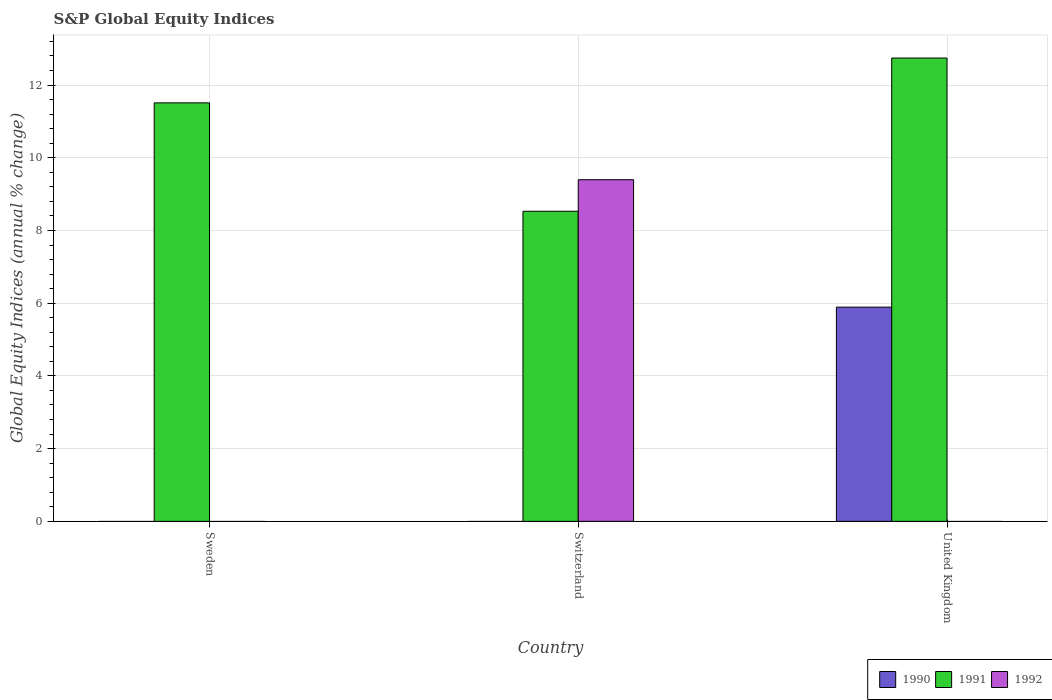Are the number of bars per tick equal to the number of legend labels?
Give a very brief answer. No. How many bars are there on the 3rd tick from the right?
Ensure brevity in your answer.  1. What is the global equity indices in 1990 in Sweden?
Make the answer very short. 0. Across all countries, what is the maximum global equity indices in 1992?
Your answer should be very brief. 9.4. In which country was the global equity indices in 1992 maximum?
Offer a terse response. Switzerland. What is the total global equity indices in 1992 in the graph?
Ensure brevity in your answer.  9.4. What is the difference between the global equity indices in 1991 in Switzerland and that in United Kingdom?
Make the answer very short. -4.21. What is the difference between the global equity indices in 1991 in Sweden and the global equity indices in 1992 in United Kingdom?
Provide a short and direct response. 11.51. What is the average global equity indices in 1991 per country?
Your answer should be compact. 10.93. What is the ratio of the global equity indices in 1991 in Switzerland to that in United Kingdom?
Keep it short and to the point. 0.67. What is the difference between the highest and the second highest global equity indices in 1991?
Ensure brevity in your answer.  -2.98. What is the difference between the highest and the lowest global equity indices in 1991?
Ensure brevity in your answer.  4.21. In how many countries, is the global equity indices in 1991 greater than the average global equity indices in 1991 taken over all countries?
Offer a very short reply. 2. Is the sum of the global equity indices in 1991 in Switzerland and United Kingdom greater than the maximum global equity indices in 1992 across all countries?
Keep it short and to the point. Yes. Is it the case that in every country, the sum of the global equity indices in 1990 and global equity indices in 1991 is greater than the global equity indices in 1992?
Ensure brevity in your answer.  No. How many bars are there?
Give a very brief answer. 5. Are all the bars in the graph horizontal?
Make the answer very short. No. How many countries are there in the graph?
Your answer should be very brief. 3. Does the graph contain any zero values?
Make the answer very short. Yes. Does the graph contain grids?
Your answer should be very brief. Yes. What is the title of the graph?
Keep it short and to the point. S&P Global Equity Indices. Does "1970" appear as one of the legend labels in the graph?
Ensure brevity in your answer.  No. What is the label or title of the X-axis?
Your answer should be very brief. Country. What is the label or title of the Y-axis?
Offer a very short reply. Global Equity Indices (annual % change). What is the Global Equity Indices (annual % change) in 1990 in Sweden?
Offer a terse response. 0. What is the Global Equity Indices (annual % change) of 1991 in Sweden?
Make the answer very short. 11.51. What is the Global Equity Indices (annual % change) of 1992 in Sweden?
Provide a short and direct response. 0. What is the Global Equity Indices (annual % change) in 1990 in Switzerland?
Your response must be concise. 0. What is the Global Equity Indices (annual % change) of 1991 in Switzerland?
Keep it short and to the point. 8.53. What is the Global Equity Indices (annual % change) in 1992 in Switzerland?
Offer a very short reply. 9.4. What is the Global Equity Indices (annual % change) in 1990 in United Kingdom?
Ensure brevity in your answer.  5.89. What is the Global Equity Indices (annual % change) in 1991 in United Kingdom?
Provide a short and direct response. 12.74. Across all countries, what is the maximum Global Equity Indices (annual % change) of 1990?
Provide a succinct answer. 5.89. Across all countries, what is the maximum Global Equity Indices (annual % change) in 1991?
Your answer should be compact. 12.74. Across all countries, what is the maximum Global Equity Indices (annual % change) in 1992?
Keep it short and to the point. 9.4. Across all countries, what is the minimum Global Equity Indices (annual % change) of 1991?
Provide a short and direct response. 8.53. Across all countries, what is the minimum Global Equity Indices (annual % change) of 1992?
Make the answer very short. 0. What is the total Global Equity Indices (annual % change) in 1990 in the graph?
Ensure brevity in your answer.  5.89. What is the total Global Equity Indices (annual % change) in 1991 in the graph?
Give a very brief answer. 32.78. What is the total Global Equity Indices (annual % change) of 1992 in the graph?
Your response must be concise. 9.4. What is the difference between the Global Equity Indices (annual % change) in 1991 in Sweden and that in Switzerland?
Offer a very short reply. 2.98. What is the difference between the Global Equity Indices (annual % change) of 1991 in Sweden and that in United Kingdom?
Make the answer very short. -1.23. What is the difference between the Global Equity Indices (annual % change) in 1991 in Switzerland and that in United Kingdom?
Your answer should be compact. -4.21. What is the difference between the Global Equity Indices (annual % change) in 1991 in Sweden and the Global Equity Indices (annual % change) in 1992 in Switzerland?
Keep it short and to the point. 2.11. What is the average Global Equity Indices (annual % change) of 1990 per country?
Give a very brief answer. 1.96. What is the average Global Equity Indices (annual % change) in 1991 per country?
Make the answer very short. 10.93. What is the average Global Equity Indices (annual % change) in 1992 per country?
Your response must be concise. 3.13. What is the difference between the Global Equity Indices (annual % change) in 1991 and Global Equity Indices (annual % change) in 1992 in Switzerland?
Offer a very short reply. -0.87. What is the difference between the Global Equity Indices (annual % change) of 1990 and Global Equity Indices (annual % change) of 1991 in United Kingdom?
Your response must be concise. -6.85. What is the ratio of the Global Equity Indices (annual % change) in 1991 in Sweden to that in Switzerland?
Give a very brief answer. 1.35. What is the ratio of the Global Equity Indices (annual % change) of 1991 in Sweden to that in United Kingdom?
Your answer should be very brief. 0.9. What is the ratio of the Global Equity Indices (annual % change) of 1991 in Switzerland to that in United Kingdom?
Give a very brief answer. 0.67. What is the difference between the highest and the second highest Global Equity Indices (annual % change) in 1991?
Ensure brevity in your answer.  1.23. What is the difference between the highest and the lowest Global Equity Indices (annual % change) in 1990?
Keep it short and to the point. 5.89. What is the difference between the highest and the lowest Global Equity Indices (annual % change) of 1991?
Your answer should be compact. 4.21. What is the difference between the highest and the lowest Global Equity Indices (annual % change) in 1992?
Make the answer very short. 9.4. 